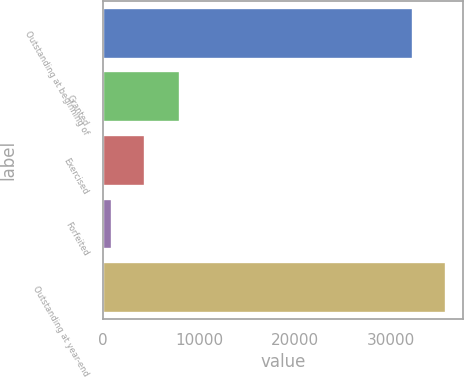Convert chart. <chart><loc_0><loc_0><loc_500><loc_500><bar_chart><fcel>Outstanding at beginning of<fcel>Granted<fcel>Exercised<fcel>Forfeited<fcel>Outstanding at year-end<nl><fcel>32301<fcel>7981<fcel>4387.9<fcel>931<fcel>35757.9<nl></chart> 